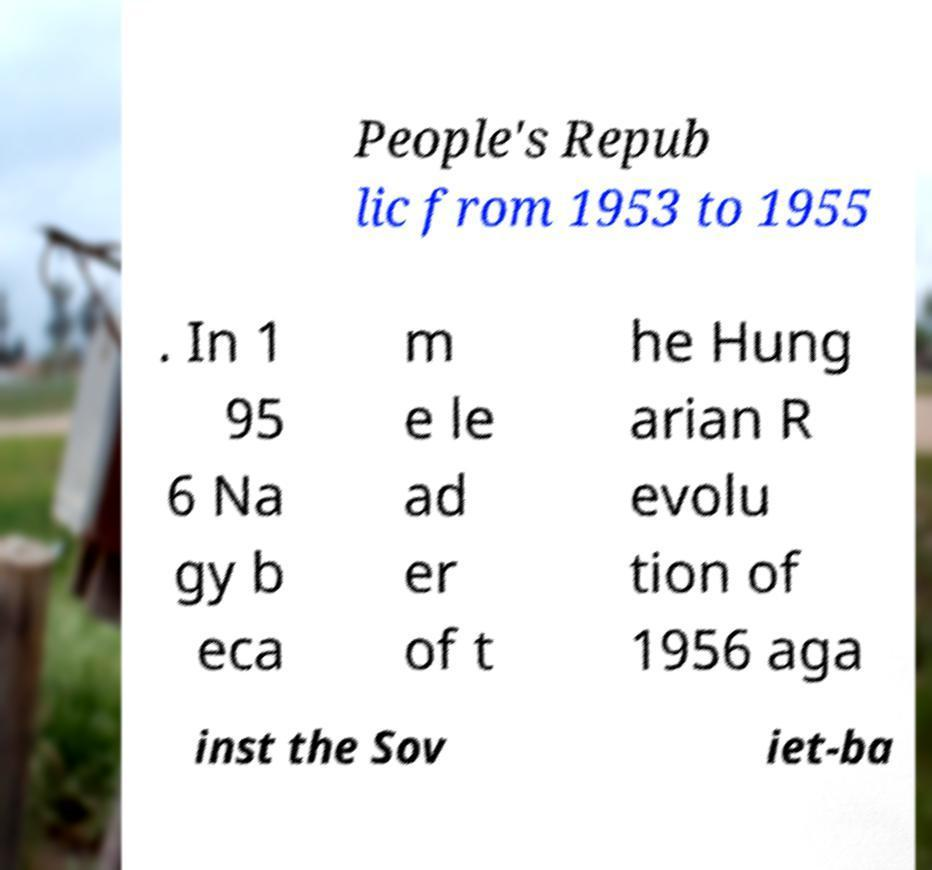Please identify and transcribe the text found in this image. People's Repub lic from 1953 to 1955 . In 1 95 6 Na gy b eca m e le ad er of t he Hung arian R evolu tion of 1956 aga inst the Sov iet-ba 